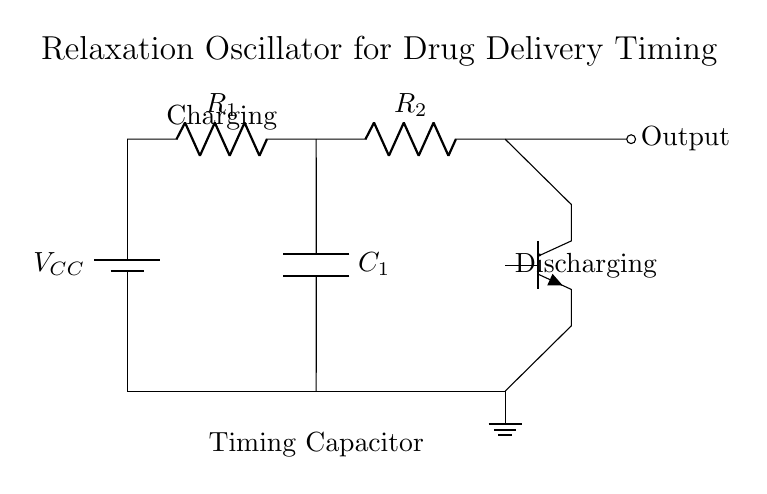What type of oscillator is depicted in the circuit? The circuit is labeled as a relaxation oscillator, which is specifically designed to produce timing signals. This is indicated at the top section of the diagram, where "Relaxation Oscillator for Drug Delivery Timing" is mentioned.
Answer: relaxation oscillator What components are used for timing in this circuit? The timing in this circuit is primarily governed by the capacitor labeled C1 and the resistors labeled R1 and R2. The behavior of these components determines the charging and discharging cycles that result in oscillation.
Answer: C1, R1, R2 What is the function of the transistor in this oscillator? The transistor (Q1) acts as a switch in this circuit, enabling the rapid charging and discharging of the capacitor, which generates the timing pulses necessary for oscillation. This control of current flow is what allows the relaxation oscillator to function effectively.
Answer: switch What happens during the charging phase of the capacitor? During the charging phase, the capacitor C1 is connected to the voltage source, allowing it to accumulate charge until it reaches a specific threshold voltage. This phase is crucial for initiating the oscillation cycle, as it eventually leads to the discharging phase when the threshold is reached.
Answer: accumulates charge How does the output signal relate to the capacitor's behavior? The output signal reflects the oscillation generated by the charging and discharging of the capacitor C1. When the capacitor discharges, it triggers the transistor to switch states, creating a pulse in the output that corresponds to the timing signal needed for the automated drug delivery system.
Answer: pulses What is the role of resistors R1 and R2 in this circuit? Resistors R1 and R2 are responsible for determining the time constant of the charging and discharging cycles of the capacitor. Their values, in conjunction with the capacitor, regulate the frequency of the oscillation, impacting how rapidly the timing signals are generated.
Answer: time constant 